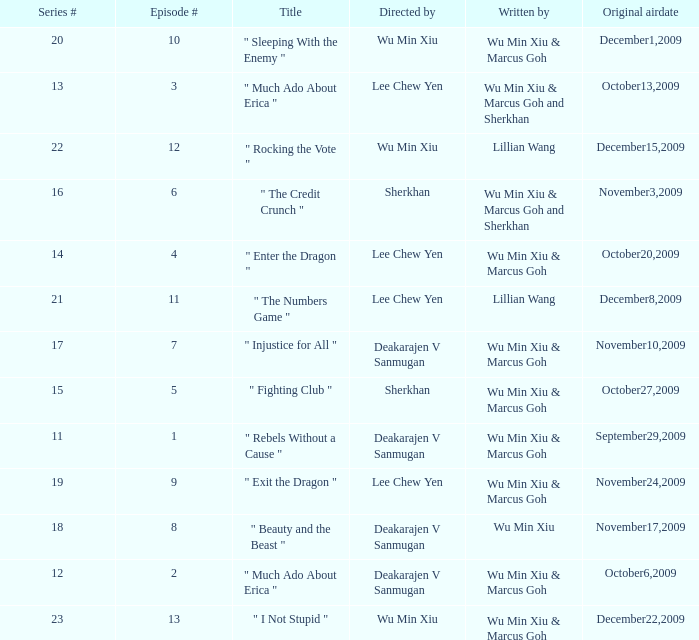What was the title for episode 2? " Much Ado About Erica ". Help me parse the entirety of this table. {'header': ['Series #', 'Episode #', 'Title', 'Directed by', 'Written by', 'Original airdate'], 'rows': [['20', '10', '" Sleeping With the Enemy "', 'Wu Min Xiu', 'Wu Min Xiu & Marcus Goh', 'December1,2009'], ['13', '3', '" Much Ado About Erica "', 'Lee Chew Yen', 'Wu Min Xiu & Marcus Goh and Sherkhan', 'October13,2009'], ['22', '12', '" Rocking the Vote "', 'Wu Min Xiu', 'Lillian Wang', 'December15,2009'], ['16', '6', '" The Credit Crunch "', 'Sherkhan', 'Wu Min Xiu & Marcus Goh and Sherkhan', 'November3,2009'], ['14', '4', '" Enter the Dragon "', 'Lee Chew Yen', 'Wu Min Xiu & Marcus Goh', 'October20,2009'], ['21', '11', '" The Numbers Game "', 'Lee Chew Yen', 'Lillian Wang', 'December8,2009'], ['17', '7', '" Injustice for All "', 'Deakarajen V Sanmugan', 'Wu Min Xiu & Marcus Goh', 'November10,2009'], ['15', '5', '" Fighting Club "', 'Sherkhan', 'Wu Min Xiu & Marcus Goh', 'October27,2009'], ['11', '1', '" Rebels Without a Cause "', 'Deakarajen V Sanmugan', 'Wu Min Xiu & Marcus Goh', 'September29,2009'], ['19', '9', '" Exit the Dragon "', 'Lee Chew Yen', 'Wu Min Xiu & Marcus Goh', 'November24,2009'], ['18', '8', '" Beauty and the Beast "', 'Deakarajen V Sanmugan', 'Wu Min Xiu', 'November17,2009'], ['12', '2', '" Much Ado About Erica "', 'Deakarajen V Sanmugan', 'Wu Min Xiu & Marcus Goh', 'October6,2009'], ['23', '13', '" I Not Stupid "', 'Wu Min Xiu', 'Wu Min Xiu & Marcus Goh', 'December22,2009']]} 